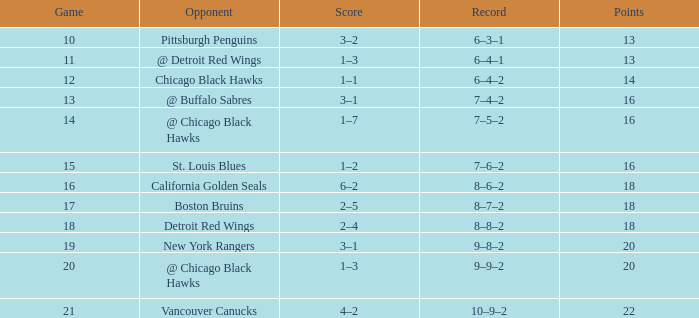What record has a november greater than 11, and st. louis blues as the opponent? 7–6–2. 